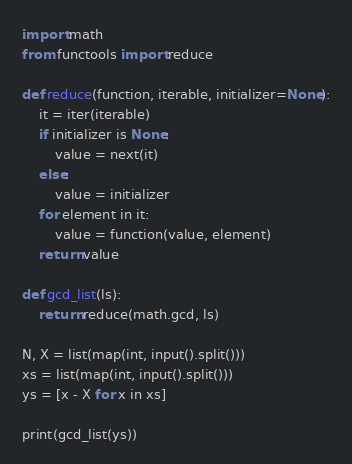<code> <loc_0><loc_0><loc_500><loc_500><_Python_>import math
from functools import reduce

def reduce(function, iterable, initializer=None):
    it = iter(iterable)
    if initializer is None:
        value = next(it)
    else:
        value = initializer
    for element in it:
        value = function(value, element)
    return value

def gcd_list(ls):
    return reduce(math.gcd, ls)

N, X = list(map(int, input().split()))
xs = list(map(int, input().split()))
ys = [x - X for x in xs]

print(gcd_list(ys))</code> 